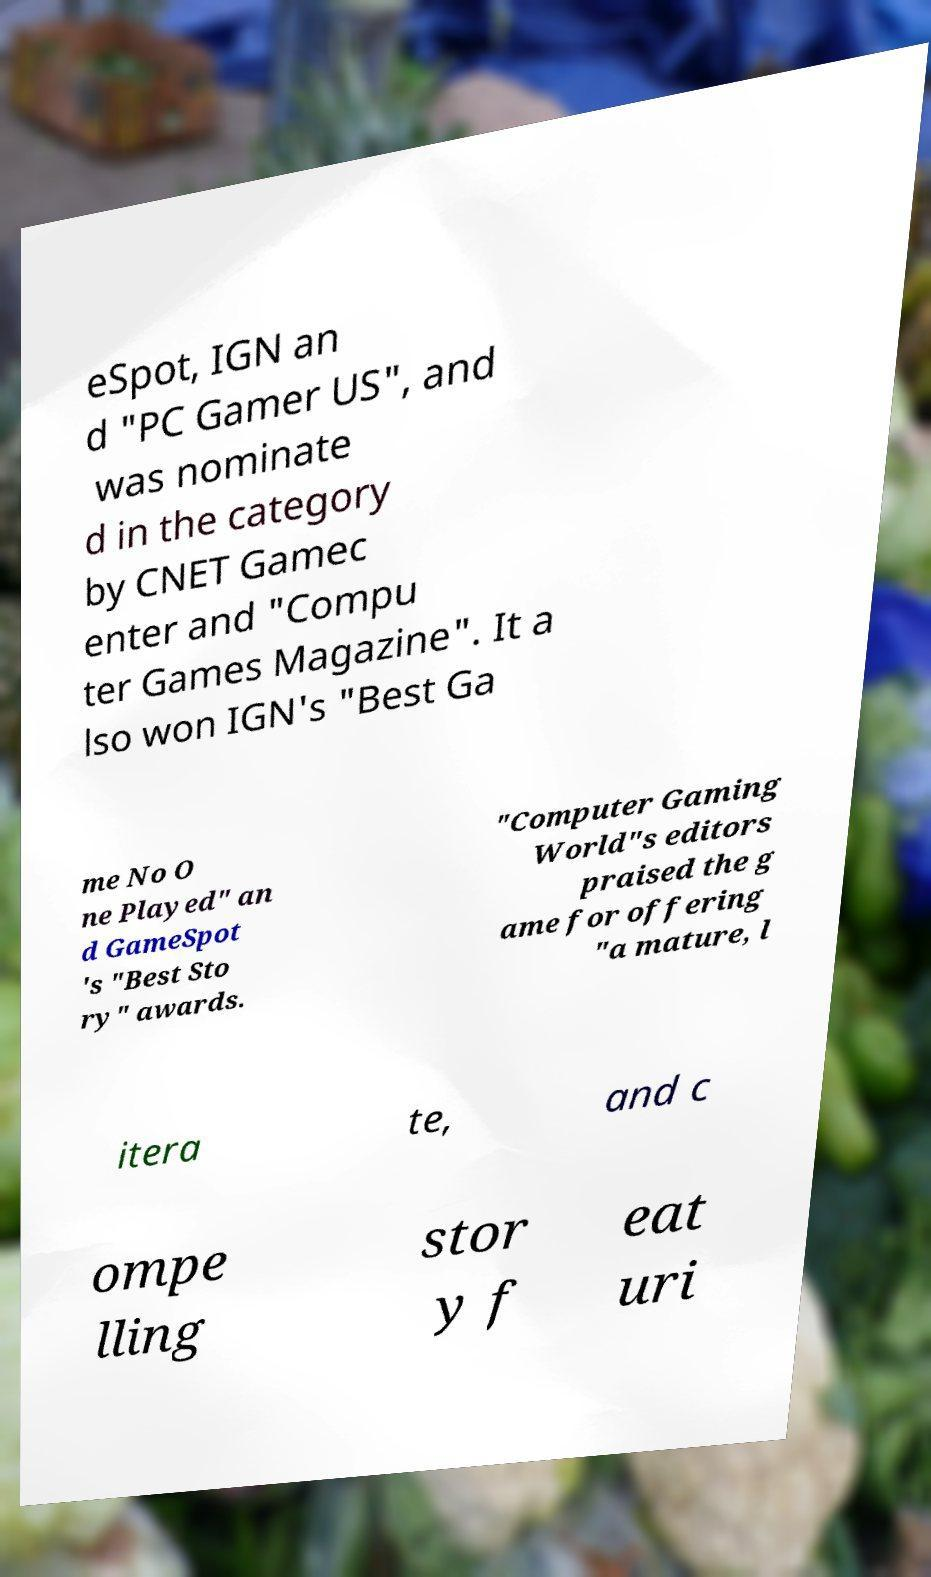Please read and relay the text visible in this image. What does it say? eSpot, IGN an d "PC Gamer US", and was nominate d in the category by CNET Gamec enter and "Compu ter Games Magazine". It a lso won IGN's "Best Ga me No O ne Played" an d GameSpot 's "Best Sto ry" awards. "Computer Gaming World"s editors praised the g ame for offering "a mature, l itera te, and c ompe lling stor y f eat uri 